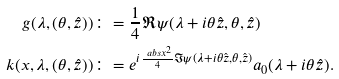Convert formula to latex. <formula><loc_0><loc_0><loc_500><loc_500>g ( \lambda , ( \theta , \hat { z } ) ) & \colon = \frac { 1 } { 4 } \Re \psi ( \lambda + i \theta \hat { z } , \theta , \hat { z } ) \\ k ( x , \lambda , ( \theta , \hat { z } ) ) & \colon = e ^ { i \frac { \ a b s { x } ^ { 2 } } { 4 } \Im \psi ( \lambda + i \theta \hat { z } , \theta , \hat { z } ) } a _ { 0 } ( \lambda + i \theta \hat { z } ) .</formula> 